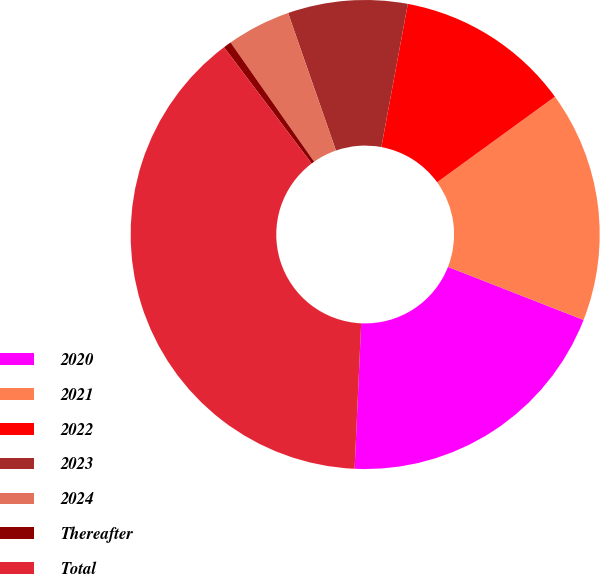Convert chart to OTSL. <chart><loc_0><loc_0><loc_500><loc_500><pie_chart><fcel>2020<fcel>2021<fcel>2022<fcel>2023<fcel>2024<fcel>Thereafter<fcel>Total<nl><fcel>19.78%<fcel>15.93%<fcel>12.09%<fcel>8.24%<fcel>4.4%<fcel>0.55%<fcel>39.0%<nl></chart> 